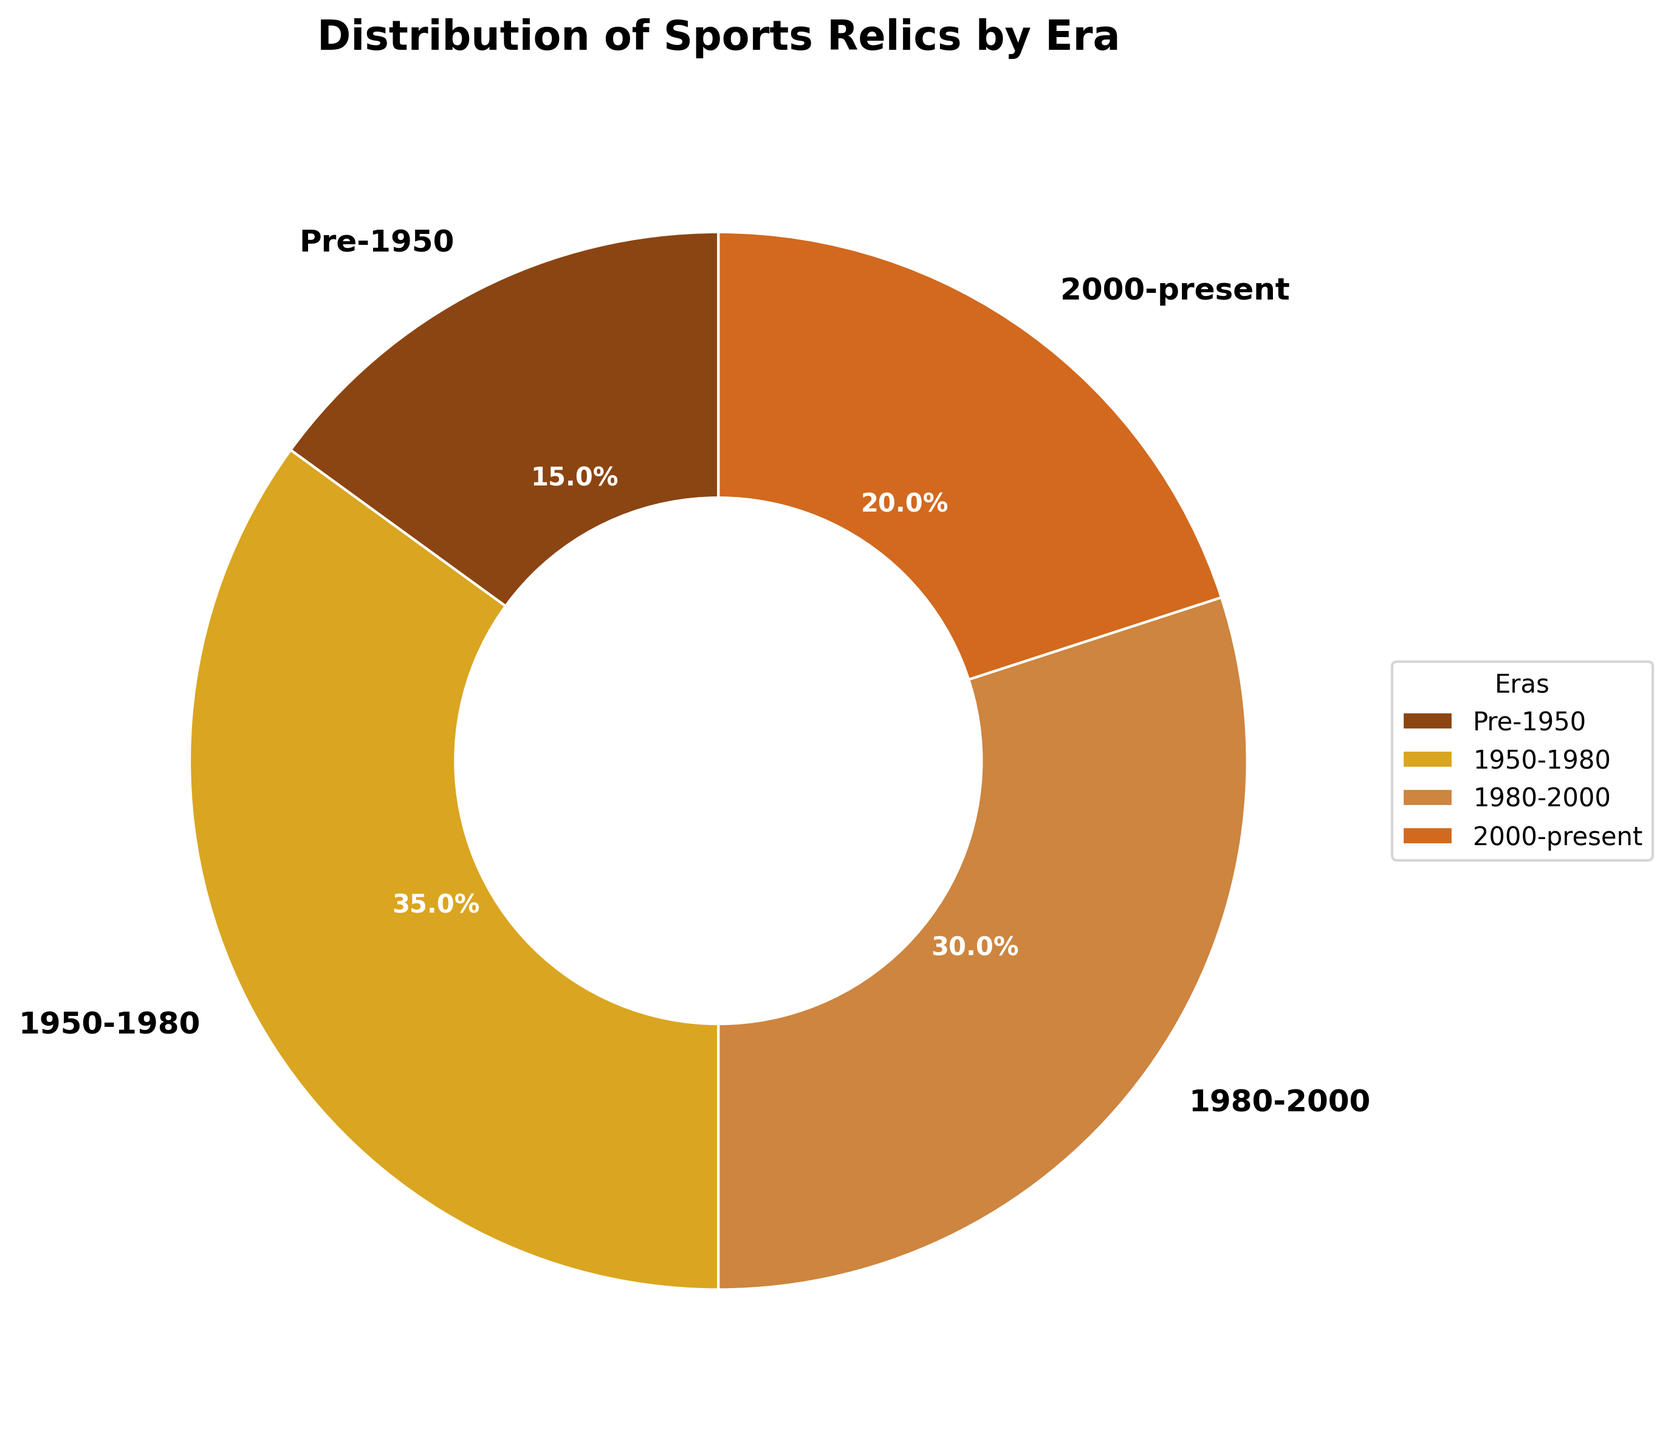What percentage of sports relics are from the era 1950-1980? The figure shows that the section labeled "1950-1980" accounts for 35% of the sports relics.
Answer: 35% Which era has the smallest percentage of sports relics? The smallest section in the pie chart corresponds to the "Pre-1950" era, which constitutes 15% of the sports relics.
Answer: Pre-1950 Which two eras together account for more than half of the sports relics? The percentages for the eras 1950-1980 and 1980-2000 are 35% and 30%, respectively. Adding these together gives 35% + 30% = 65%, which is more than half.
Answer: 1950-1980 and 1980-2000 How many eras have a percentage of sports relics greater than 20%? According to the chart, the eras 1950-1980 and 1980-2000 each have percentages greater than 20% (35% and 30%, respectively).
Answer: 2 What's the difference in percentage between sports relics from the eras 1980-2000 and 2000-present? The era 1980-2000 represents 30% and the era 2000-present represents 20%. The difference is 30% - 20% = 10%.
Answer: 10% Which era's percentage is one-third of the total sports relics? The pie chart shows that "1980-2000" accounts for 30%, which is roughly one-third of the total (100/3 ≈ 33.33%).
Answer: 1980-2000 Which era's slice is visually the largest, and by how much? The era 1950-1980 is visually the largest slice at 35%. It is larger than the next largest era, 1980-2000, by 35% - 30% = 5%.
Answer: 1950-1980 by 5% If sports relics from 1950-1980 were split evenly into two new eras (1950-1965 and 1965-1980), what would be the percentage for each of these new eras? The original era from 1950-1980 has 35%. Dividing this equally between two new eras would give each era 35% / 2 = 17.5%.
Answer: 17.5% What is the sum of the percentages for the sports relics from the eras pre-1950 and 2000-present? The percentages for the eras pre-1950 and 2000-present are 15% and 20%, respectively. Adding these together gives 15% + 20% = 35%.
Answer: 35% Does any era have exactly 30% of the sports relics? If so, which one? According to the pie chart, the "1980-2000" era has exactly 30%.
Answer: 1980-2000 